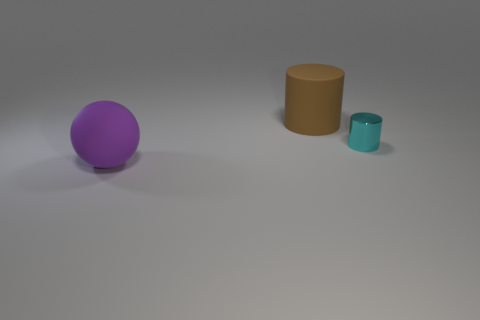Add 3 small shiny objects. How many objects exist? 6 Subtract all brown cylinders. How many cylinders are left? 1 Subtract all cylinders. How many objects are left? 1 Add 1 small brown rubber spheres. How many small brown rubber spheres exist? 1 Subtract 1 purple spheres. How many objects are left? 2 Subtract all yellow cylinders. Subtract all purple blocks. How many cylinders are left? 2 Subtract all small gray matte cubes. Subtract all small cyan metallic things. How many objects are left? 2 Add 2 large brown matte cylinders. How many large brown matte cylinders are left? 3 